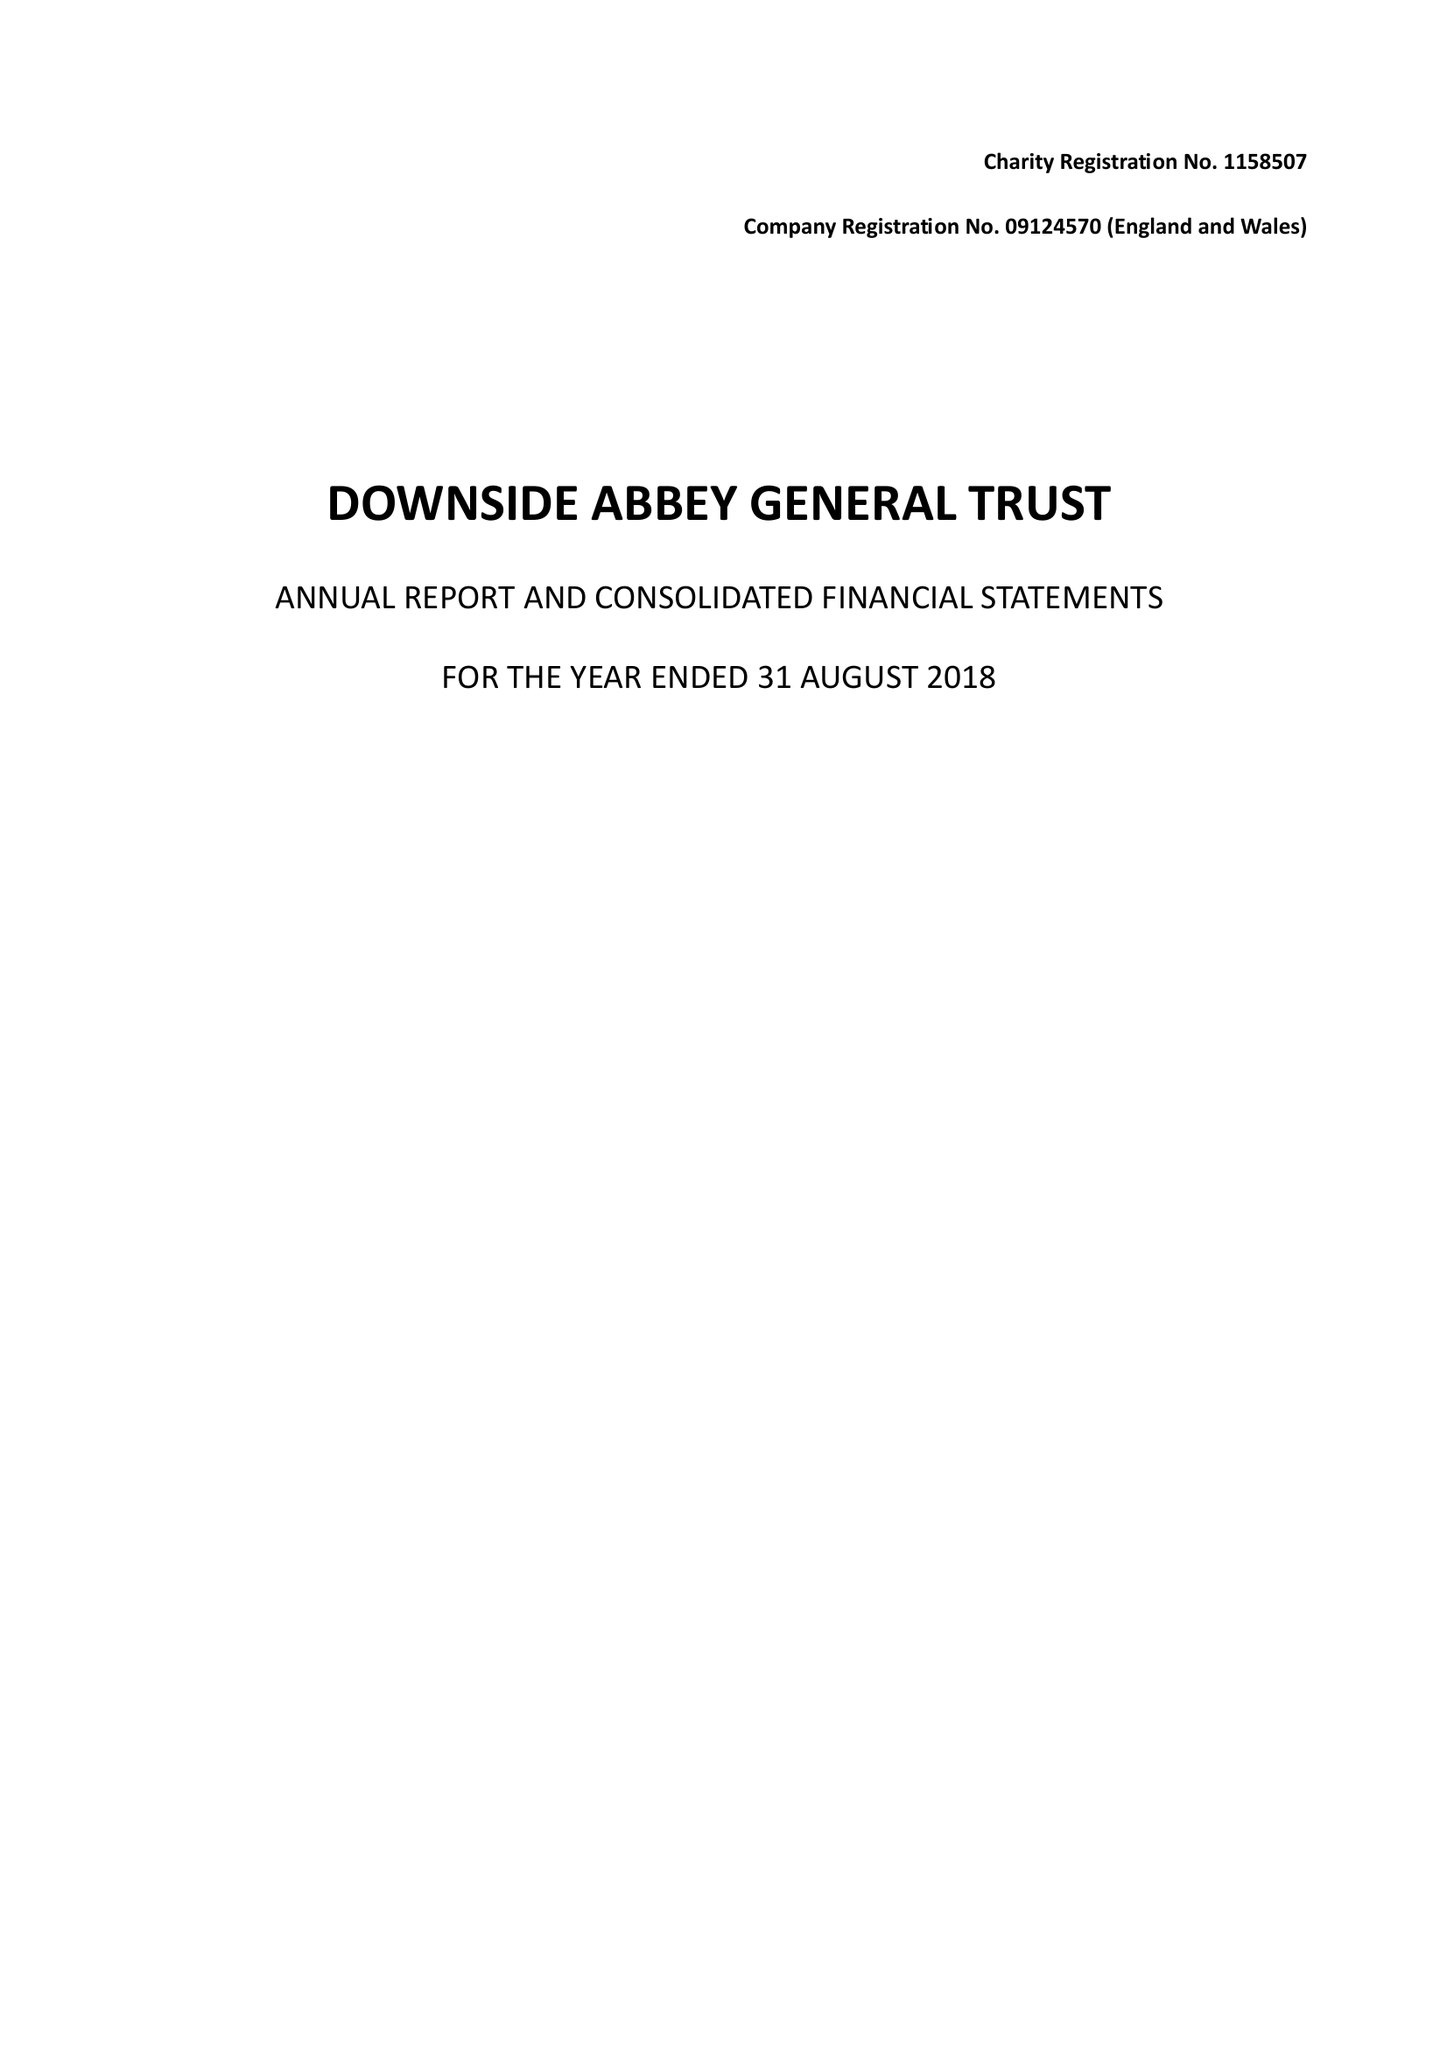What is the value for the address__street_line?
Answer the question using a single word or phrase. None 